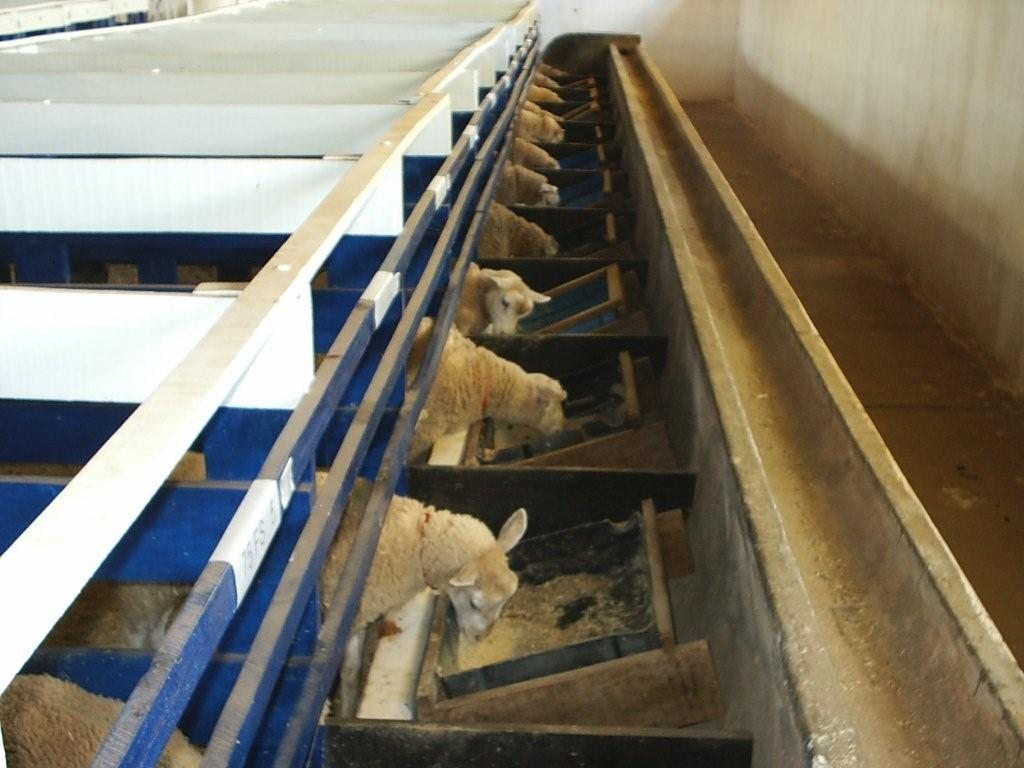What type of location is depicted in the image? The image is taken at a sheep farm. What animals can be seen in the image? Sheep are present in the image. What are the sheep doing in the image? The sheep are eating. What objects can be seen in the image besides the sheep? There are trays in the image. What feature is visible on the right side of the image? There is a path on the right side of the image. What type of creature is using the umbrella in the image? There is no creature using an umbrella in the image, as it is a scene at a sheep farm with no umbrellas present. 